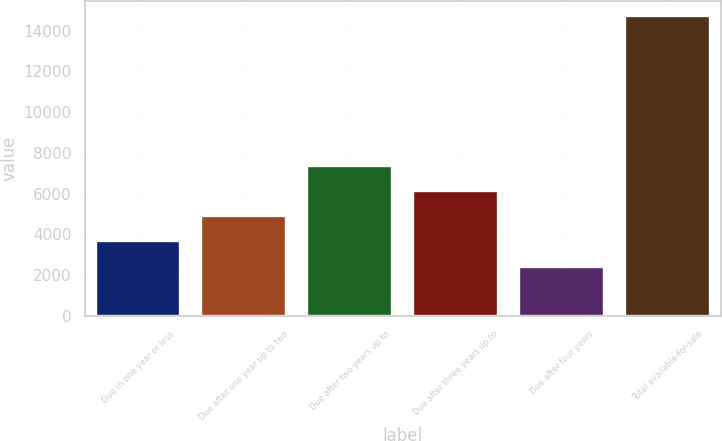Convert chart. <chart><loc_0><loc_0><loc_500><loc_500><bar_chart><fcel>Due in one year or less<fcel>Due after one year up to two<fcel>Due after two years up to<fcel>Due after three years up to<fcel>Due after four years<fcel>Total available-for-sale<nl><fcel>3658.94<fcel>4889.08<fcel>7349.36<fcel>6119.22<fcel>2428.8<fcel>14730.2<nl></chart> 